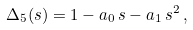Convert formula to latex. <formula><loc_0><loc_0><loc_500><loc_500>\Delta _ { 5 } ( s ) = 1 - a _ { 0 } \, s - a _ { 1 } \, s ^ { 2 } \, ,</formula> 